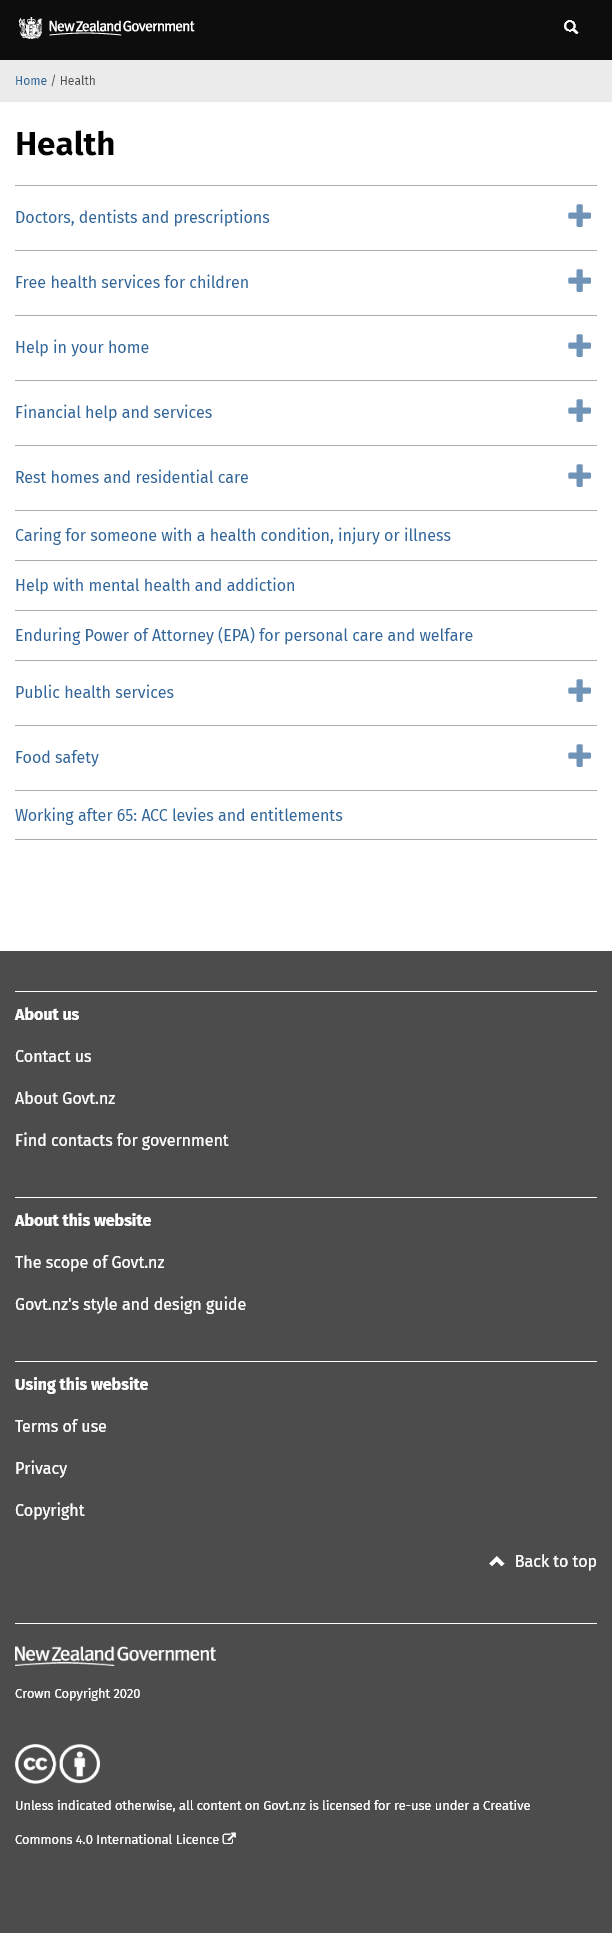Highlight a few significant elements in this photo. Yes, 'Rest homes and residential care' falls under the purview of the 'Health' section. Enduring Power of Attorney" is a type of authority granted to another person to act on one's behalf in financial and medical matters, commonly referred to as EPA. Yes, 'Food Safety' is covered under the 'Health' section. 